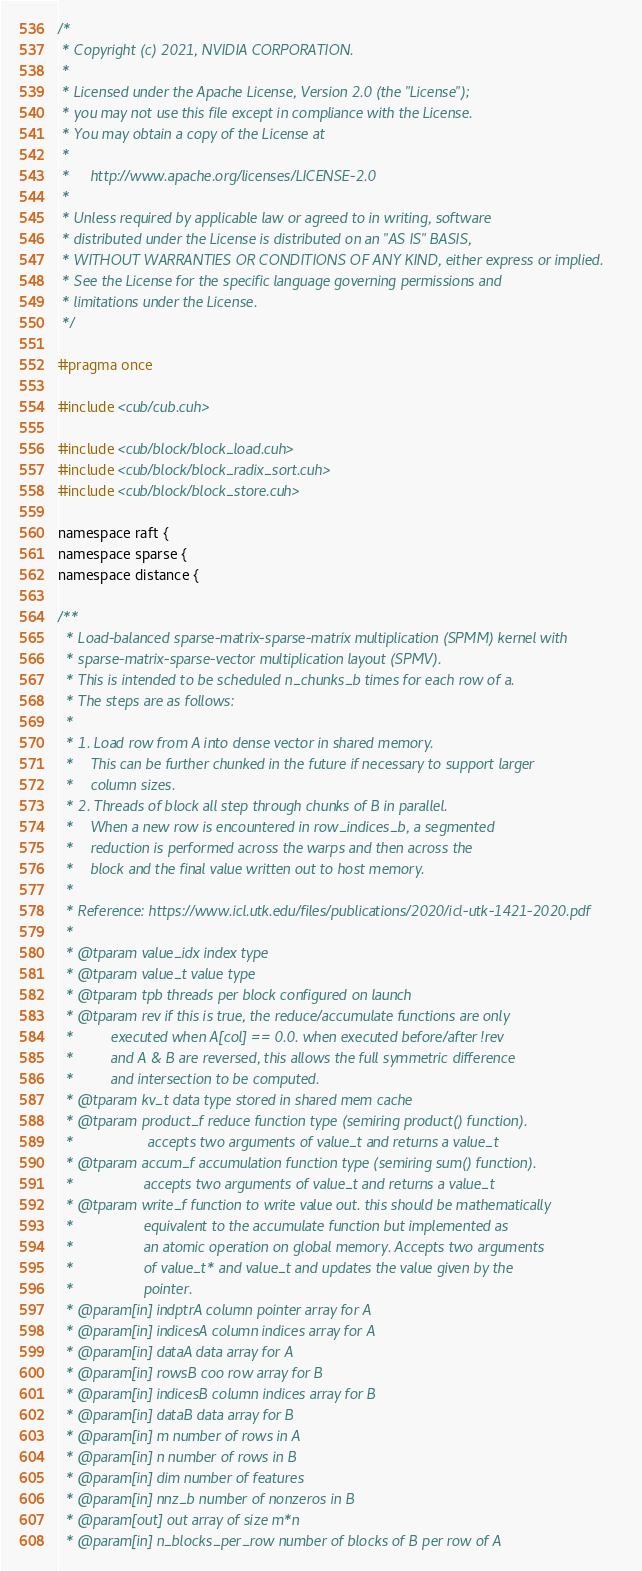<code> <loc_0><loc_0><loc_500><loc_500><_Cuda_>/*
 * Copyright (c) 2021, NVIDIA CORPORATION.
 *
 * Licensed under the Apache License, Version 2.0 (the "License");
 * you may not use this file except in compliance with the License.
 * You may obtain a copy of the License at
 *
 *     http://www.apache.org/licenses/LICENSE-2.0
 *
 * Unless required by applicable law or agreed to in writing, software
 * distributed under the License is distributed on an "AS IS" BASIS,
 * WITHOUT WARRANTIES OR CONDITIONS OF ANY KIND, either express or implied.
 * See the License for the specific language governing permissions and
 * limitations under the License.
 */

#pragma once

#include <cub/cub.cuh>

#include <cub/block/block_load.cuh>
#include <cub/block/block_radix_sort.cuh>
#include <cub/block/block_store.cuh>

namespace raft {
namespace sparse {
namespace distance {

/**
  * Load-balanced sparse-matrix-sparse-matrix multiplication (SPMM) kernel with
  * sparse-matrix-sparse-vector multiplication layout (SPMV).
  * This is intended to be scheduled n_chunks_b times for each row of a.
  * The steps are as follows:
  *
  * 1. Load row from A into dense vector in shared memory.
  *    This can be further chunked in the future if necessary to support larger
  *    column sizes.
  * 2. Threads of block all step through chunks of B in parallel.
  *    When a new row is encountered in row_indices_b, a segmented
  *    reduction is performed across the warps and then across the
  *    block and the final value written out to host memory.
  *
  * Reference: https://www.icl.utk.edu/files/publications/2020/icl-utk-1421-2020.pdf
  *
  * @tparam value_idx index type
  * @tparam value_t value type
  * @tparam tpb threads per block configured on launch
  * @tparam rev if this is true, the reduce/accumulate functions are only
  *         executed when A[col] == 0.0. when executed before/after !rev
  *         and A & B are reversed, this allows the full symmetric difference
  *         and intersection to be computed.
  * @tparam kv_t data type stored in shared mem cache
  * @tparam product_f reduce function type (semiring product() function).
  *                  accepts two arguments of value_t and returns a value_t
  * @tparam accum_f accumulation function type (semiring sum() function).
  *                 accepts two arguments of value_t and returns a value_t
  * @tparam write_f function to write value out. this should be mathematically
  *                 equivalent to the accumulate function but implemented as
  *                 an atomic operation on global memory. Accepts two arguments
  *                 of value_t* and value_t and updates the value given by the
  *                 pointer.
  * @param[in] indptrA column pointer array for A
  * @param[in] indicesA column indices array for A
  * @param[in] dataA data array for A
  * @param[in] rowsB coo row array for B
  * @param[in] indicesB column indices array for B
  * @param[in] dataB data array for B
  * @param[in] m number of rows in A
  * @param[in] n number of rows in B
  * @param[in] dim number of features
  * @param[in] nnz_b number of nonzeros in B
  * @param[out] out array of size m*n
  * @param[in] n_blocks_per_row number of blocks of B per row of A</code> 